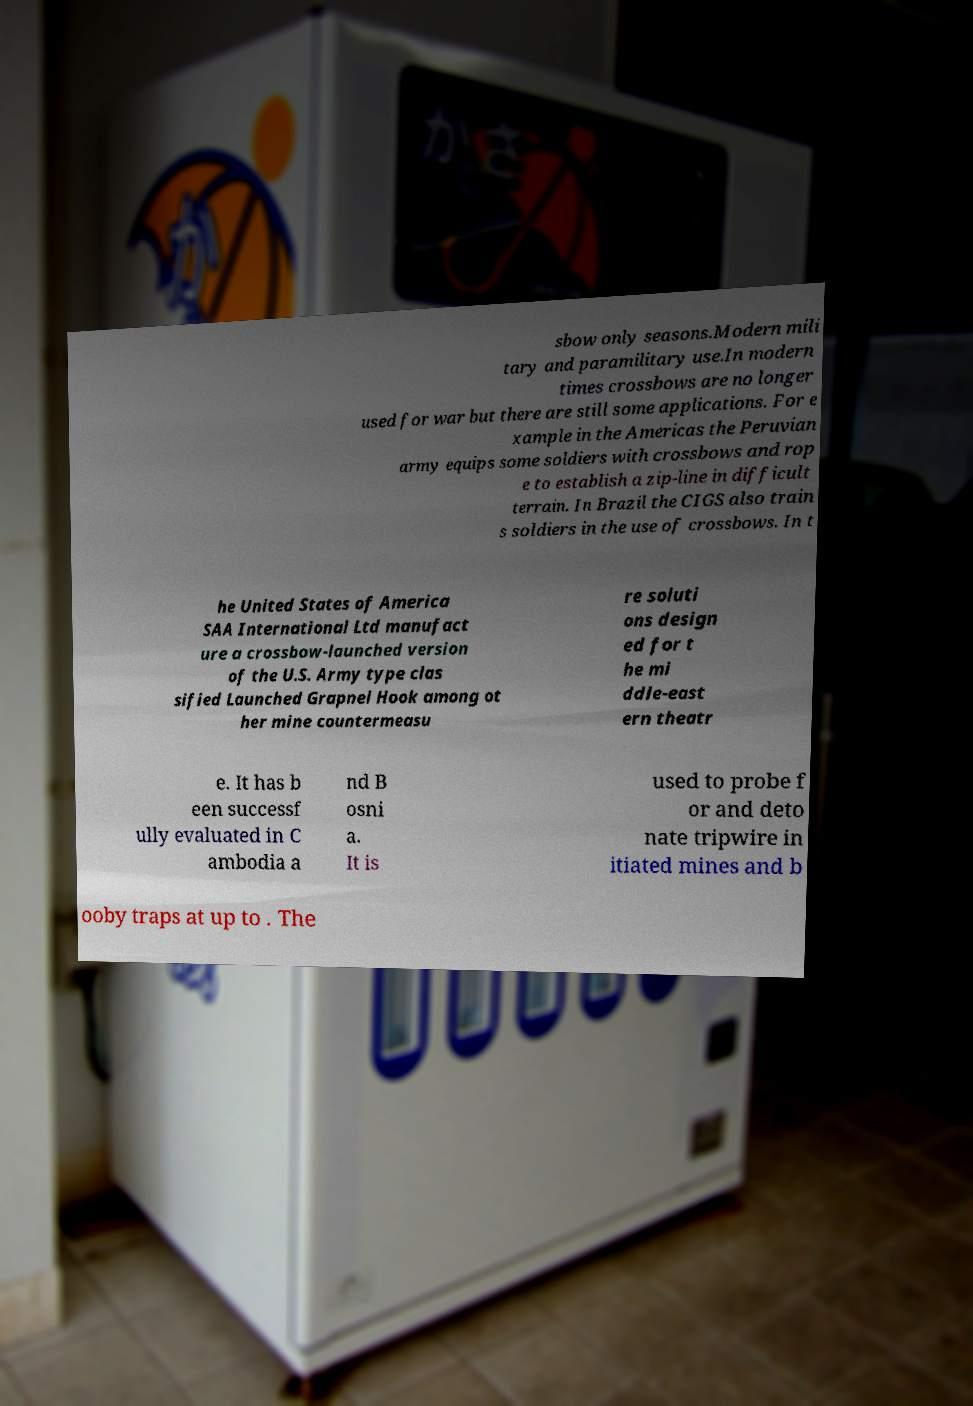For documentation purposes, I need the text within this image transcribed. Could you provide that? sbow only seasons.Modern mili tary and paramilitary use.In modern times crossbows are no longer used for war but there are still some applications. For e xample in the Americas the Peruvian army equips some soldiers with crossbows and rop e to establish a zip-line in difficult terrain. In Brazil the CIGS also train s soldiers in the use of crossbows. In t he United States of America SAA International Ltd manufact ure a crossbow-launched version of the U.S. Army type clas sified Launched Grapnel Hook among ot her mine countermeasu re soluti ons design ed for t he mi ddle-east ern theatr e. It has b een successf ully evaluated in C ambodia a nd B osni a. It is used to probe f or and deto nate tripwire in itiated mines and b ooby traps at up to . The 